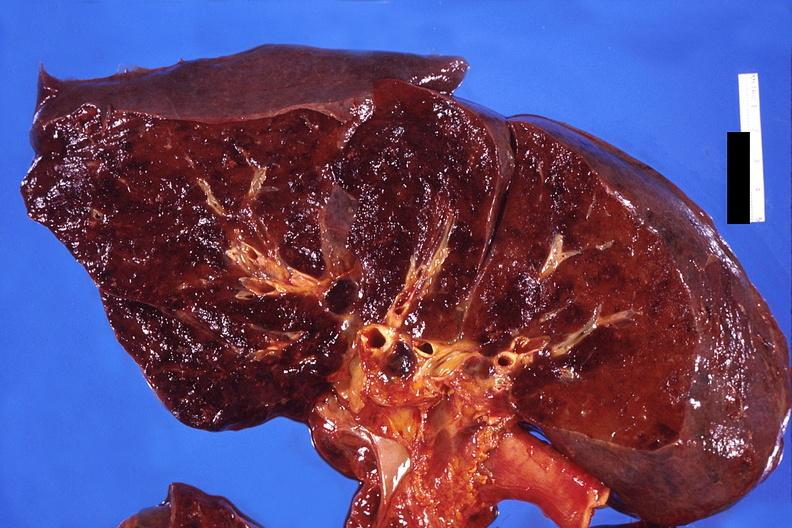what is present?
Answer the question using a single word or phrase. Respiratory 